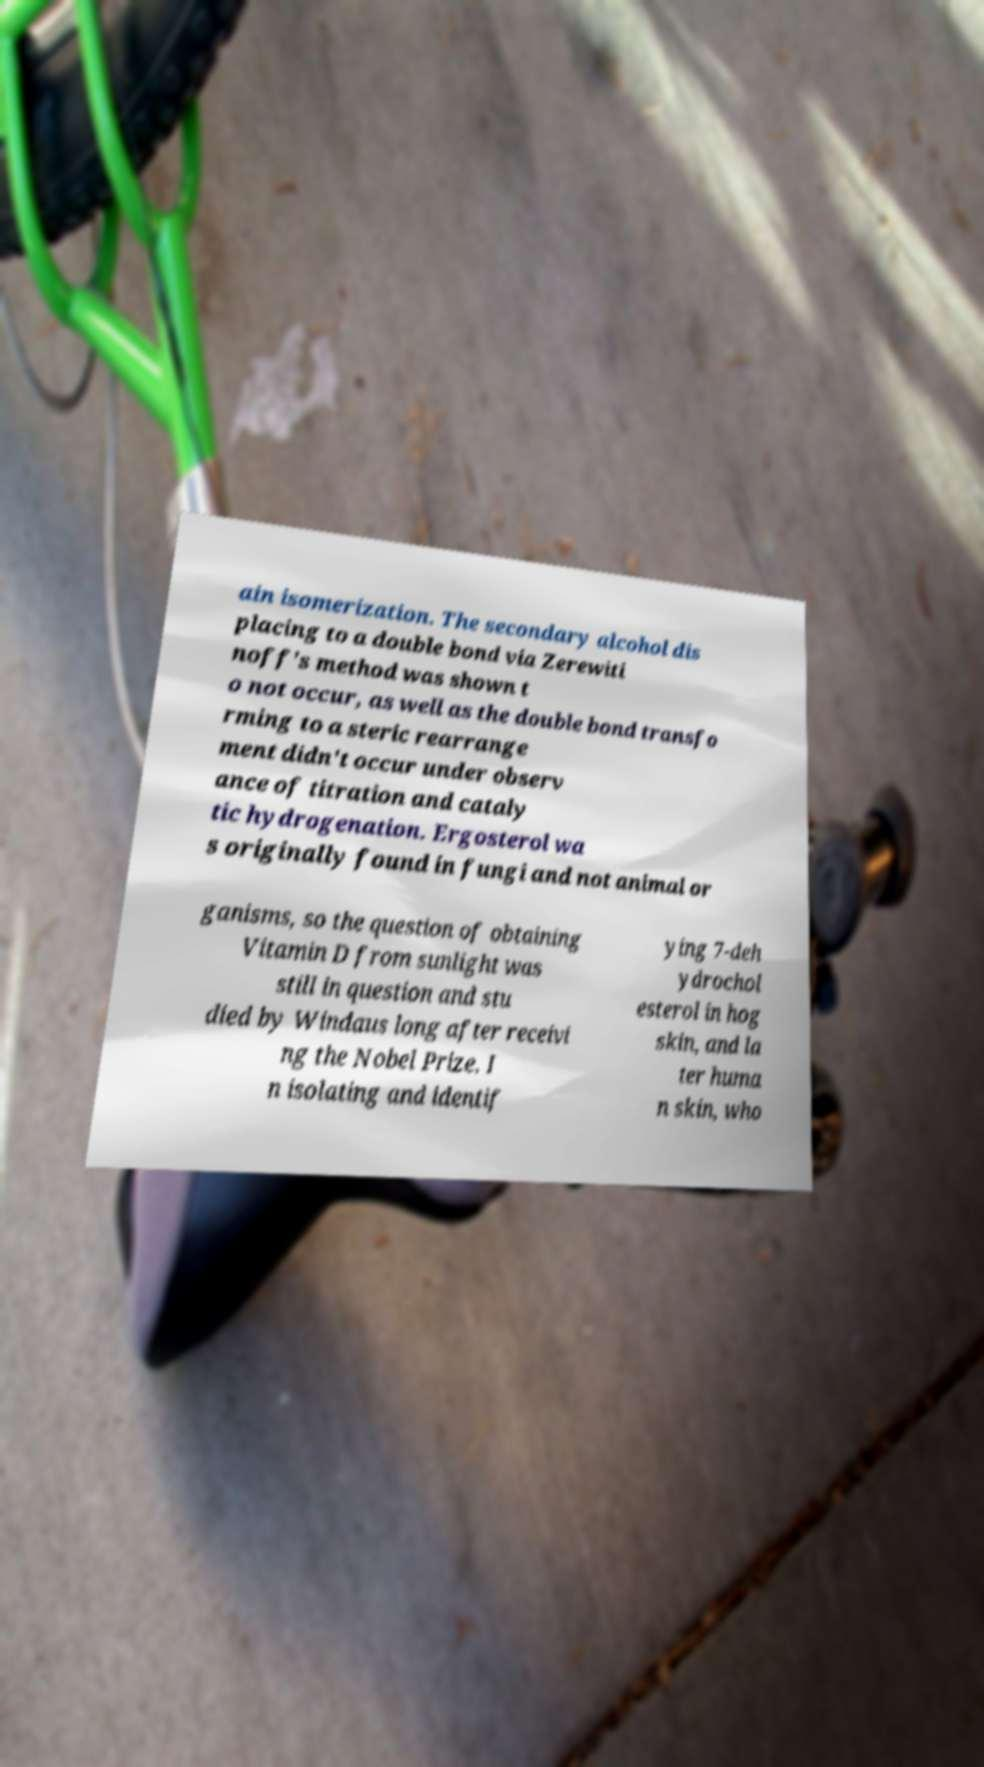Can you read and provide the text displayed in the image?This photo seems to have some interesting text. Can you extract and type it out for me? ain isomerization. The secondary alcohol dis placing to a double bond via Zerewiti noff's method was shown t o not occur, as well as the double bond transfo rming to a steric rearrange ment didn't occur under observ ance of titration and cataly tic hydrogenation. Ergosterol wa s originally found in fungi and not animal or ganisms, so the question of obtaining Vitamin D from sunlight was still in question and stu died by Windaus long after receivi ng the Nobel Prize. I n isolating and identif ying 7-deh ydrochol esterol in hog skin, and la ter huma n skin, who 